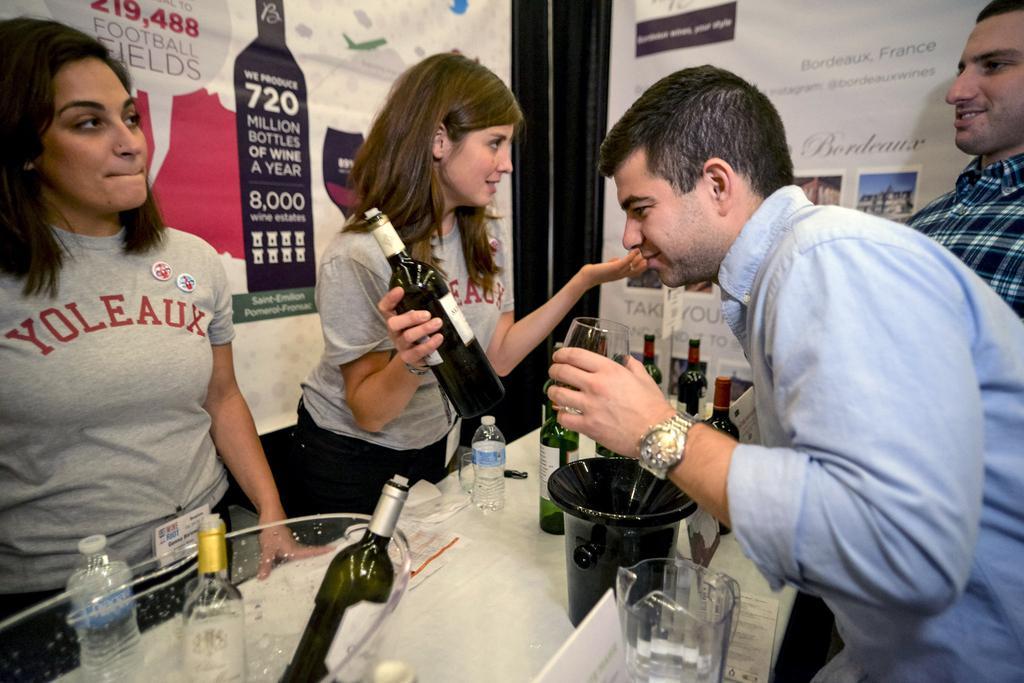Please provide a concise description of this image. There are two women and two men standing. This is a table. I can see a water bottle, small bucket, wine bottles, glass tumblers, name board, papers and few other things are placed on the table. I think these are the banners. This woman is holding a bottle in her hand and the man is holding a wine glass. 